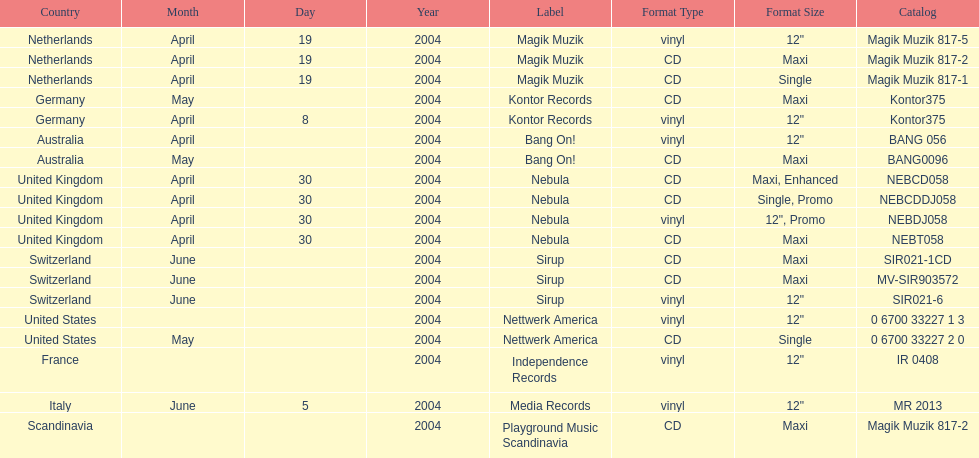What label was italy on? Media Records. 